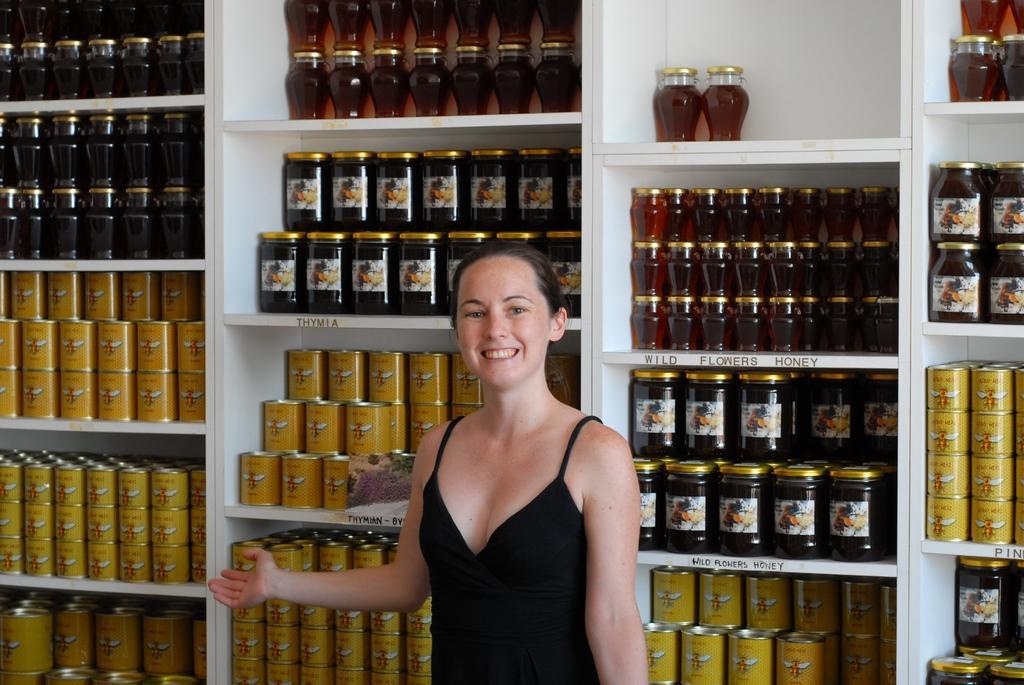Could you give a brief overview of what you see in this image? In this picture we can see a woman standing and smiling and at the back of her we can see jars in racks. 